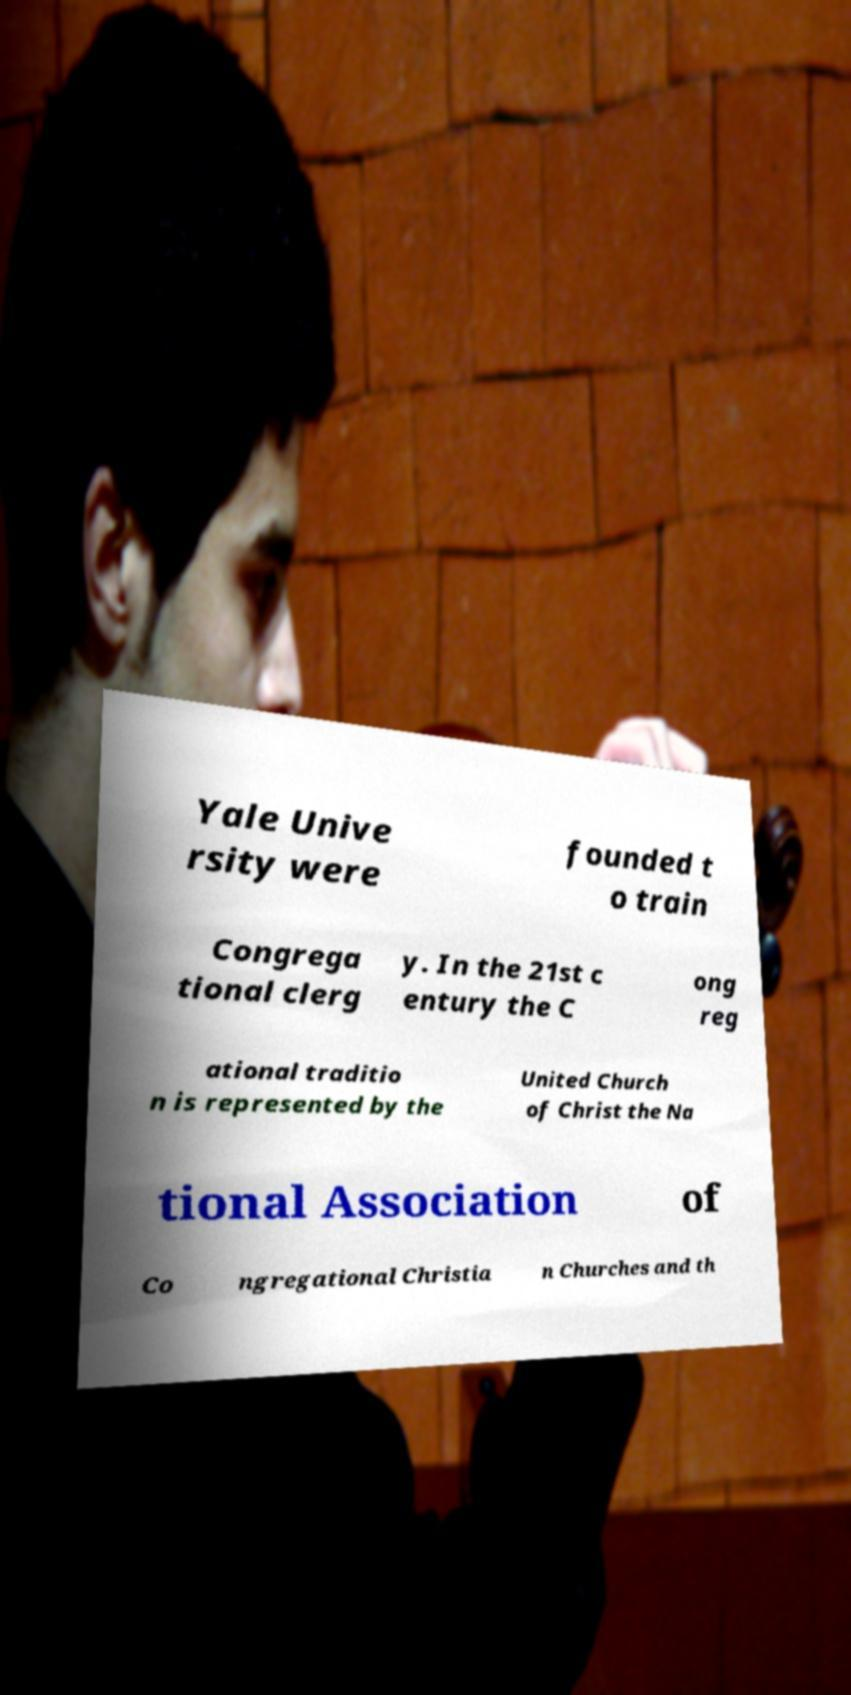Could you extract and type out the text from this image? Yale Unive rsity were founded t o train Congrega tional clerg y. In the 21st c entury the C ong reg ational traditio n is represented by the United Church of Christ the Na tional Association of Co ngregational Christia n Churches and th 